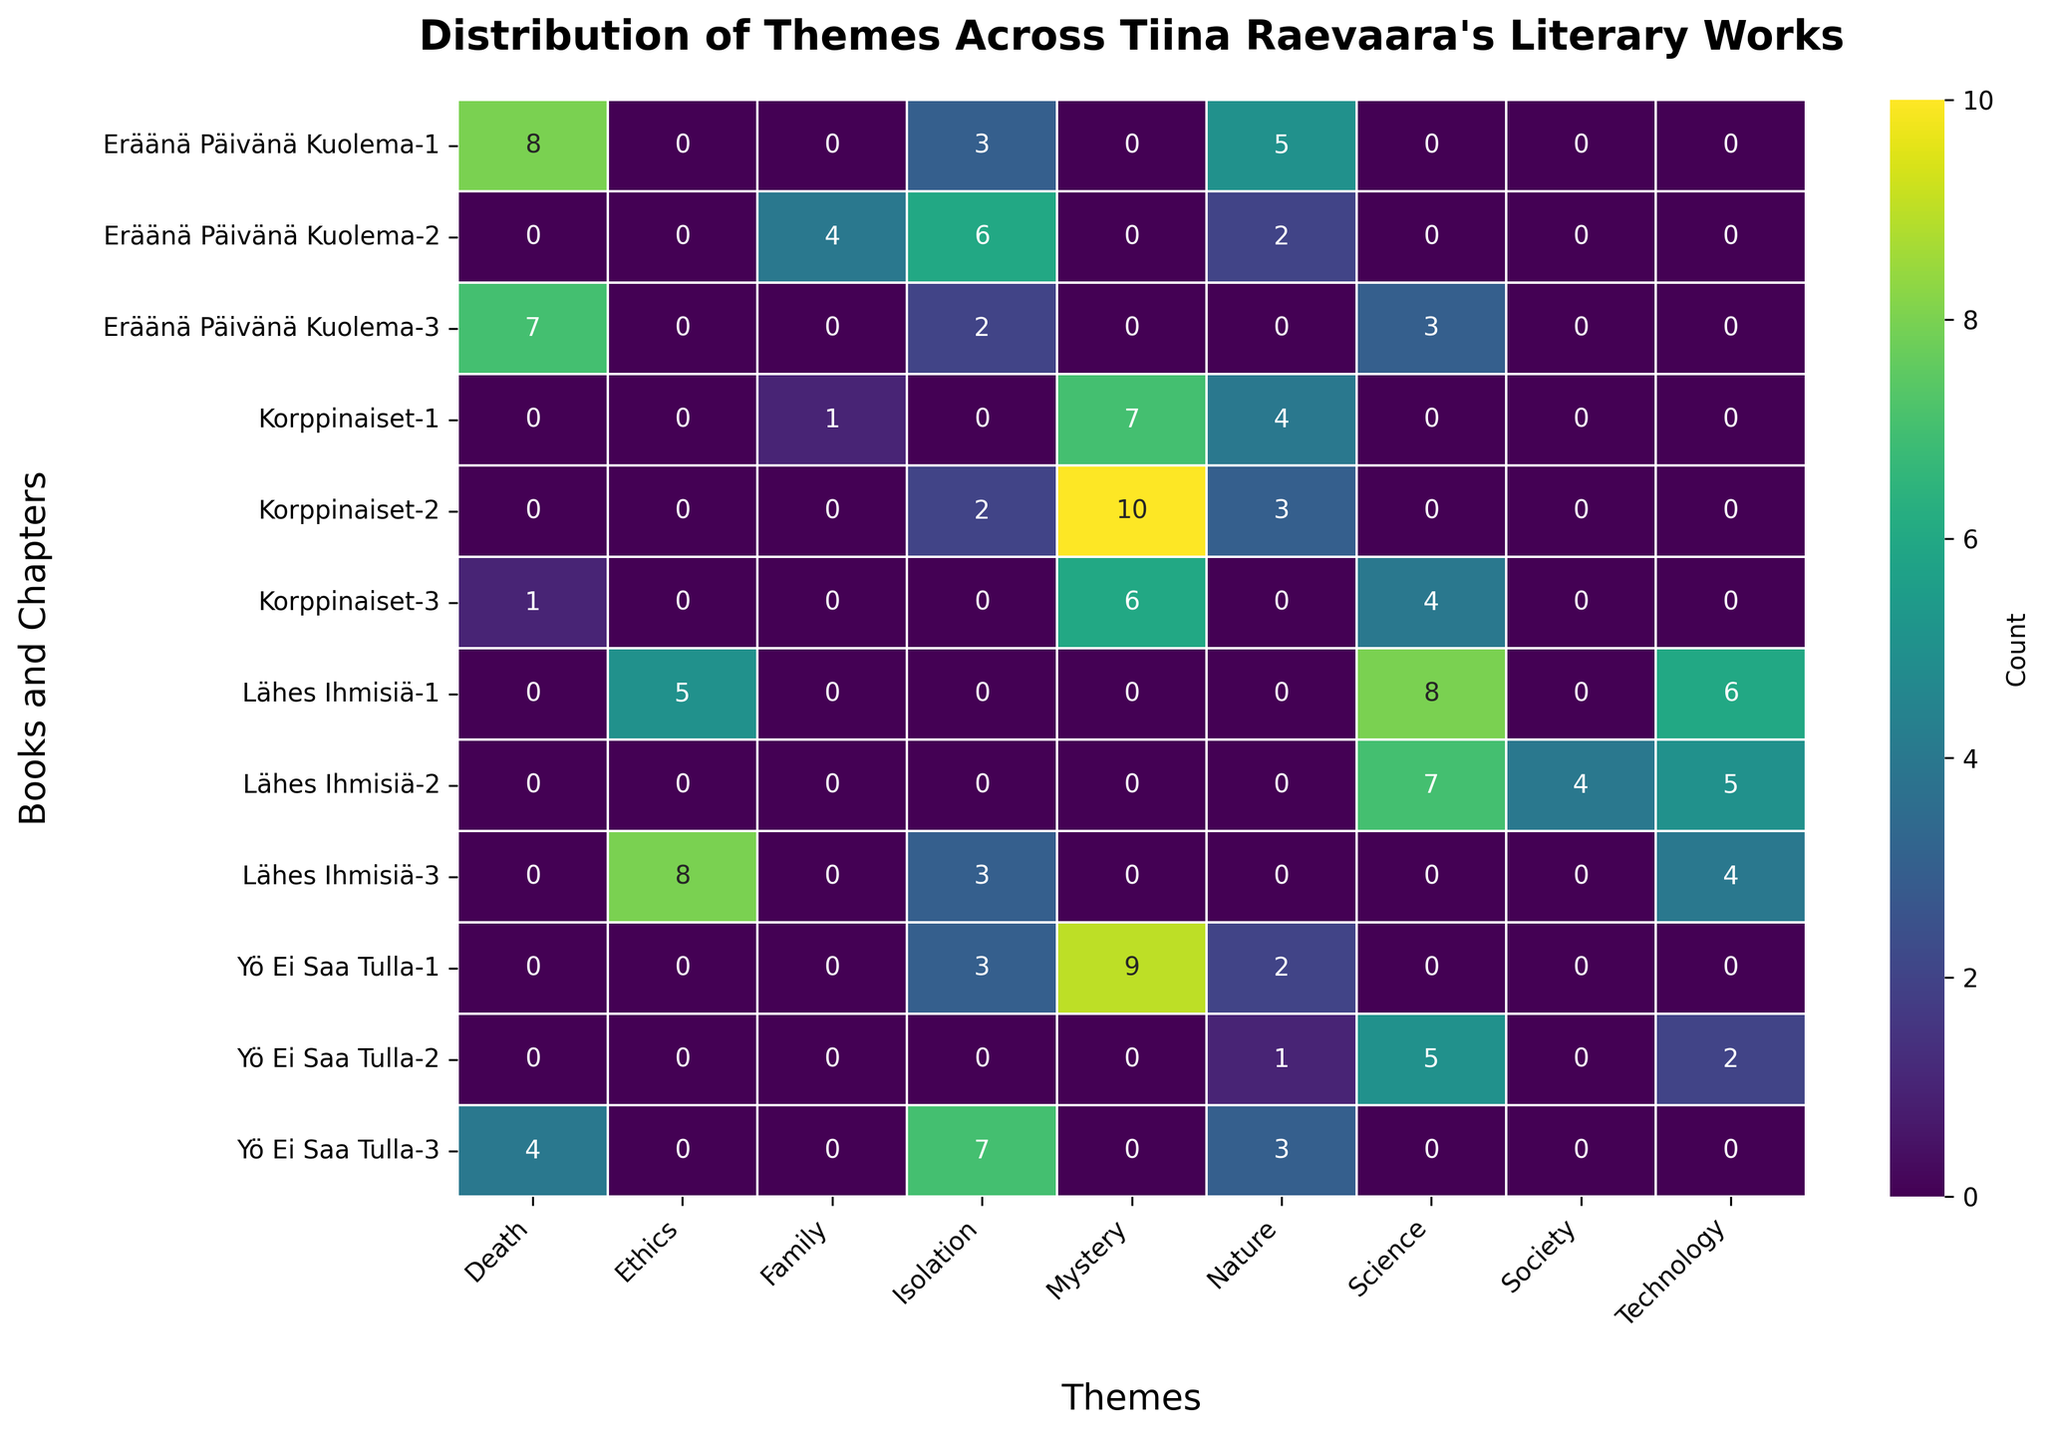Which theme appears most frequently in the book "Eräänä Päivänä Kuolema"? Refer to the rows of the heatmap corresponding to "Eräänä Päivänä Kuolema" and identify the theme with the highest cumulative count across its chapters. "Death" appears frequently with counts 8 and 7, totalling 15.
Answer: Death Which chapter in "Korppinaiset" has the highest count for the theme "Mystery"? Look at the "Korppinaiset" rows and compare the "Mystery" counts for each chapter. Chapter 2 has the highest count with 10.
Answer: Chapter 2 How many total instances of the theme "Science" are present in "Lähes Ihmisiä"? Sum the counts of "Science" theme across all chapters of "Lähes Ihmisiä". The counts are 8 (Chapter 1) and 7 (Chapter 2), making a total of 15.
Answer: 15 Compare the occurrence of "Isolation" in Chapters 2 and 3 of "Yö Ei Saa Tulla". Which one is higher? Look at the "Isolation" counts in Chapters 2 and 3 of "Yö Ei Saa Tulla". Chapter 3 has 7, while Chapter 2 has 0, making Chapter 3 higher.
Answer: Chapter 3 What is the total count of the theme "Nature" across all books? Sum the counts of "Nature" theme across all rows. The counts are 5, 2, 4, 3, 2, 3, and 1, giving a total of 20.
Answer: 20 Which theme has the lowest occurrence in "Lähes Ihmisiä"? Identify the lowest count values for each theme in "Lähes Ihmisiä". "Society" has the lowest count of 4 in Chapter 2.
Answer: Society In which book and chapter does the theme "Ethics" occur most frequently? Check the counts of "Ethics" across all books and chapters. It occurs the most in "Lähes Ihmisiä" Chapter 3 with a count of 8.
Answer: Lähes Ihmisiä, Chapter 3 Compare the total number of instances of themes "Technology" between "Lähes Ihmisiä" and "Yö Ei Saa Tulla". Which book has a higher count? Sum the counts of "Technology" in "Lähes Ihmisiä" (6 and 5) and "Yö Ei Saa Tulla" (2), yielding 15 for "Lähes Ihmisiä" and 2 for "Yö Ei Saa Tulla".
Answer: Lähes Ihmisiä Is the total occurrence of "Mystery" higher than "Nature" in "Korppinaiset"? Sum the counts of "Mystery" (7, 10, 6) and "Nature" (4, 3) in "Korppinaiset". "Mystery" totals 23, while "Nature" totals 7, making "Mystery" higher.
Answer: Yes 